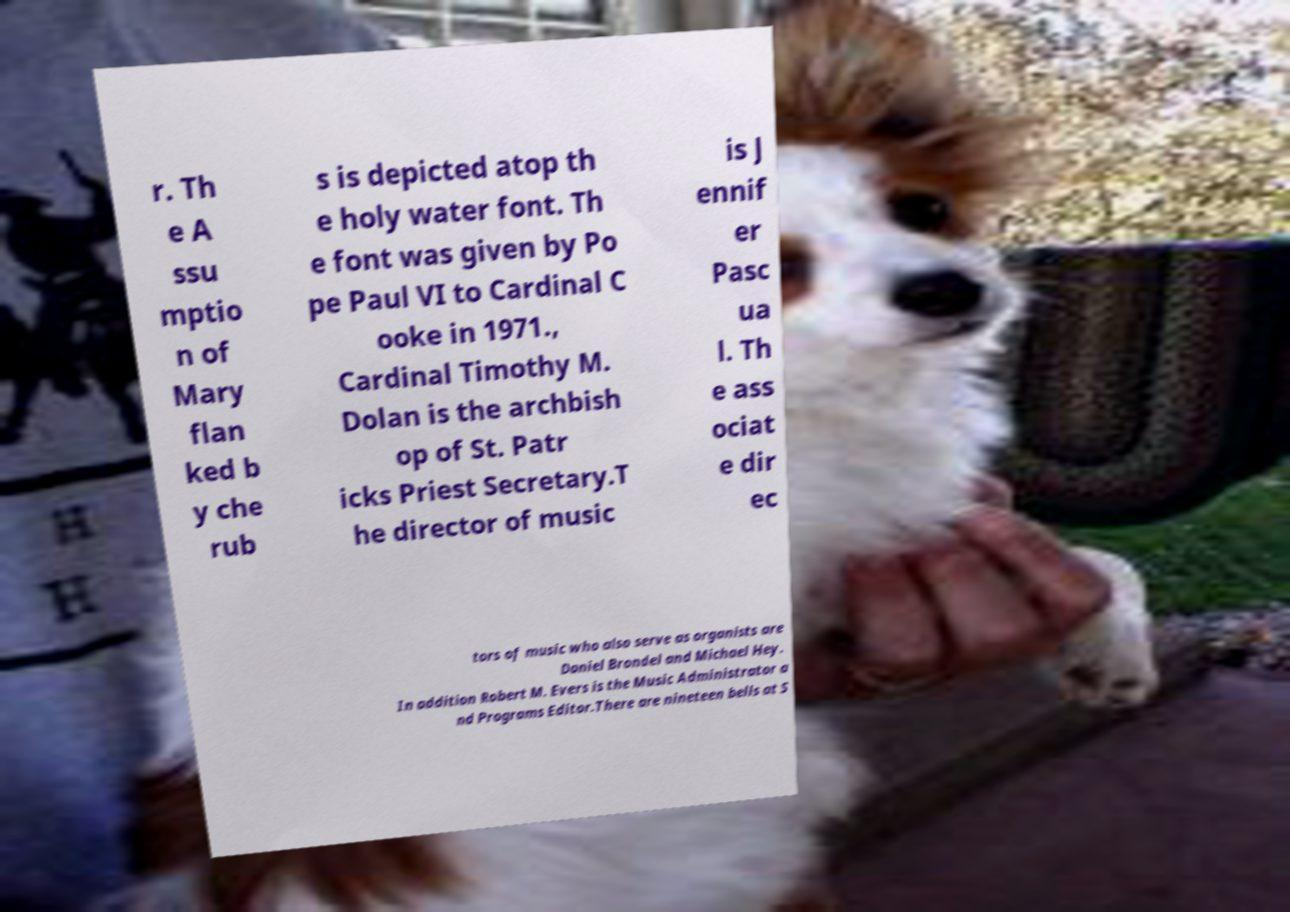Can you read and provide the text displayed in the image?This photo seems to have some interesting text. Can you extract and type it out for me? r. Th e A ssu mptio n of Mary flan ked b y che rub s is depicted atop th e holy water font. Th e font was given by Po pe Paul VI to Cardinal C ooke in 1971., Cardinal Timothy M. Dolan is the archbish op of St. Patr icks Priest Secretary.T he director of music is J ennif er Pasc ua l. Th e ass ociat e dir ec tors of music who also serve as organists are Daniel Brondel and Michael Hey. In addition Robert M. Evers is the Music Administrator a nd Programs Editor.There are nineteen bells at S 